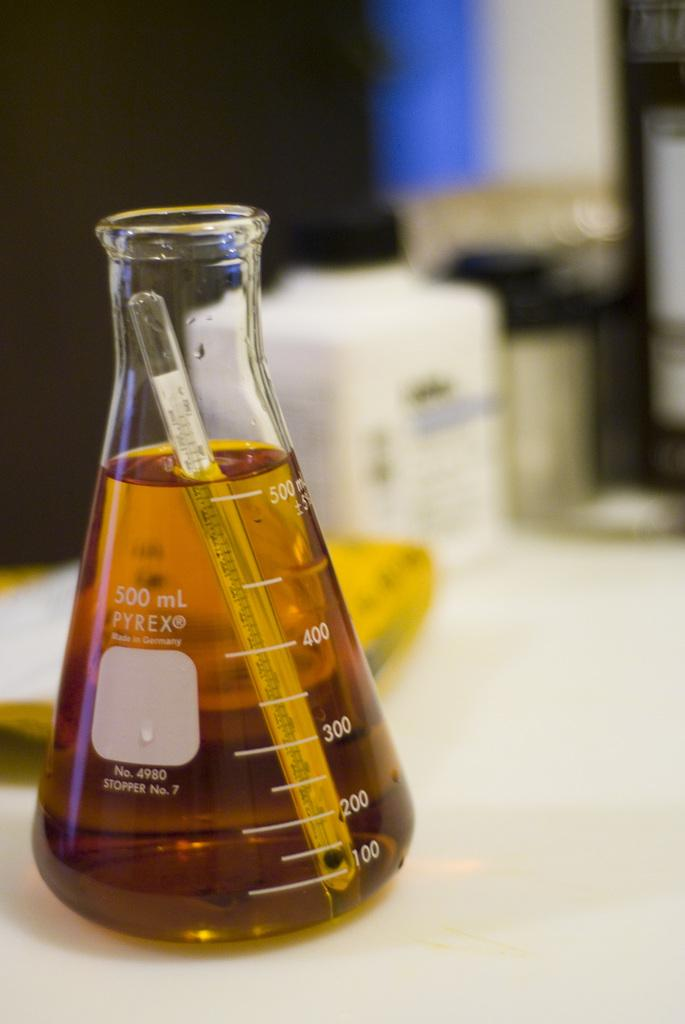Provide a one-sentence caption for the provided image. A measuring glass that can hold 500 millileters. 